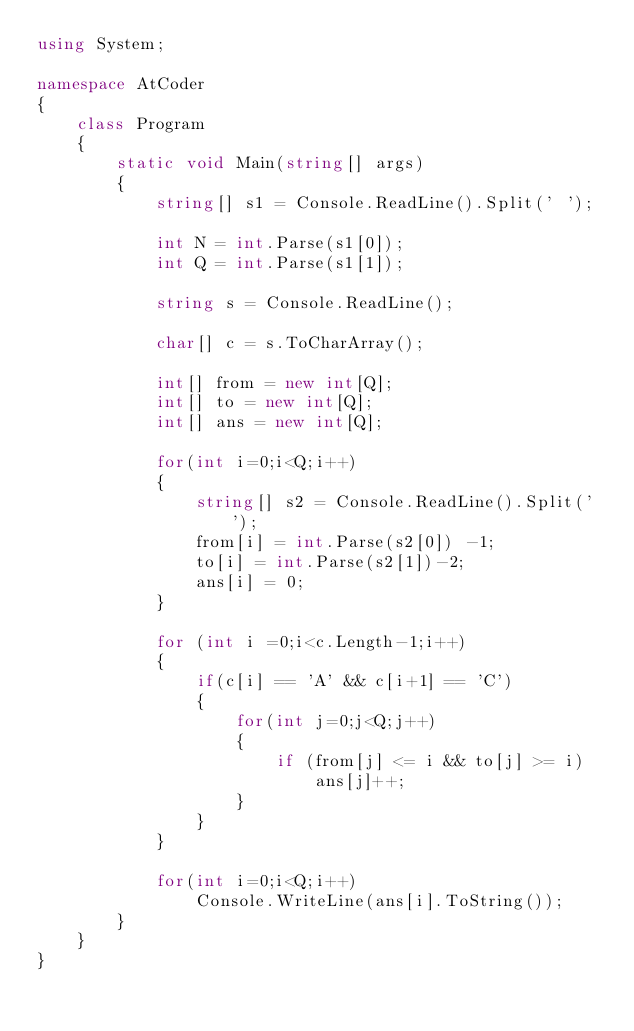<code> <loc_0><loc_0><loc_500><loc_500><_C#_>using System;

namespace AtCoder
{
    class Program
    {
        static void Main(string[] args)
        {
            string[] s1 = Console.ReadLine().Split(' ');

            int N = int.Parse(s1[0]);
            int Q = int.Parse(s1[1]);

            string s = Console.ReadLine();

            char[] c = s.ToCharArray();

            int[] from = new int[Q];
            int[] to = new int[Q];
            int[] ans = new int[Q];

            for(int i=0;i<Q;i++)
            {
                string[] s2 = Console.ReadLine().Split(' ');
                from[i] = int.Parse(s2[0]) -1;
                to[i] = int.Parse(s2[1])-2;
                ans[i] = 0;
            }

            for (int i =0;i<c.Length-1;i++)
            {
                if(c[i] == 'A' && c[i+1] == 'C')
                {
                    for(int j=0;j<Q;j++)
                    {
                        if (from[j] <= i && to[j] >= i)
                            ans[j]++;
                    }
                }
            }

            for(int i=0;i<Q;i++)
                Console.WriteLine(ans[i].ToString());
        }
    }
}
</code> 